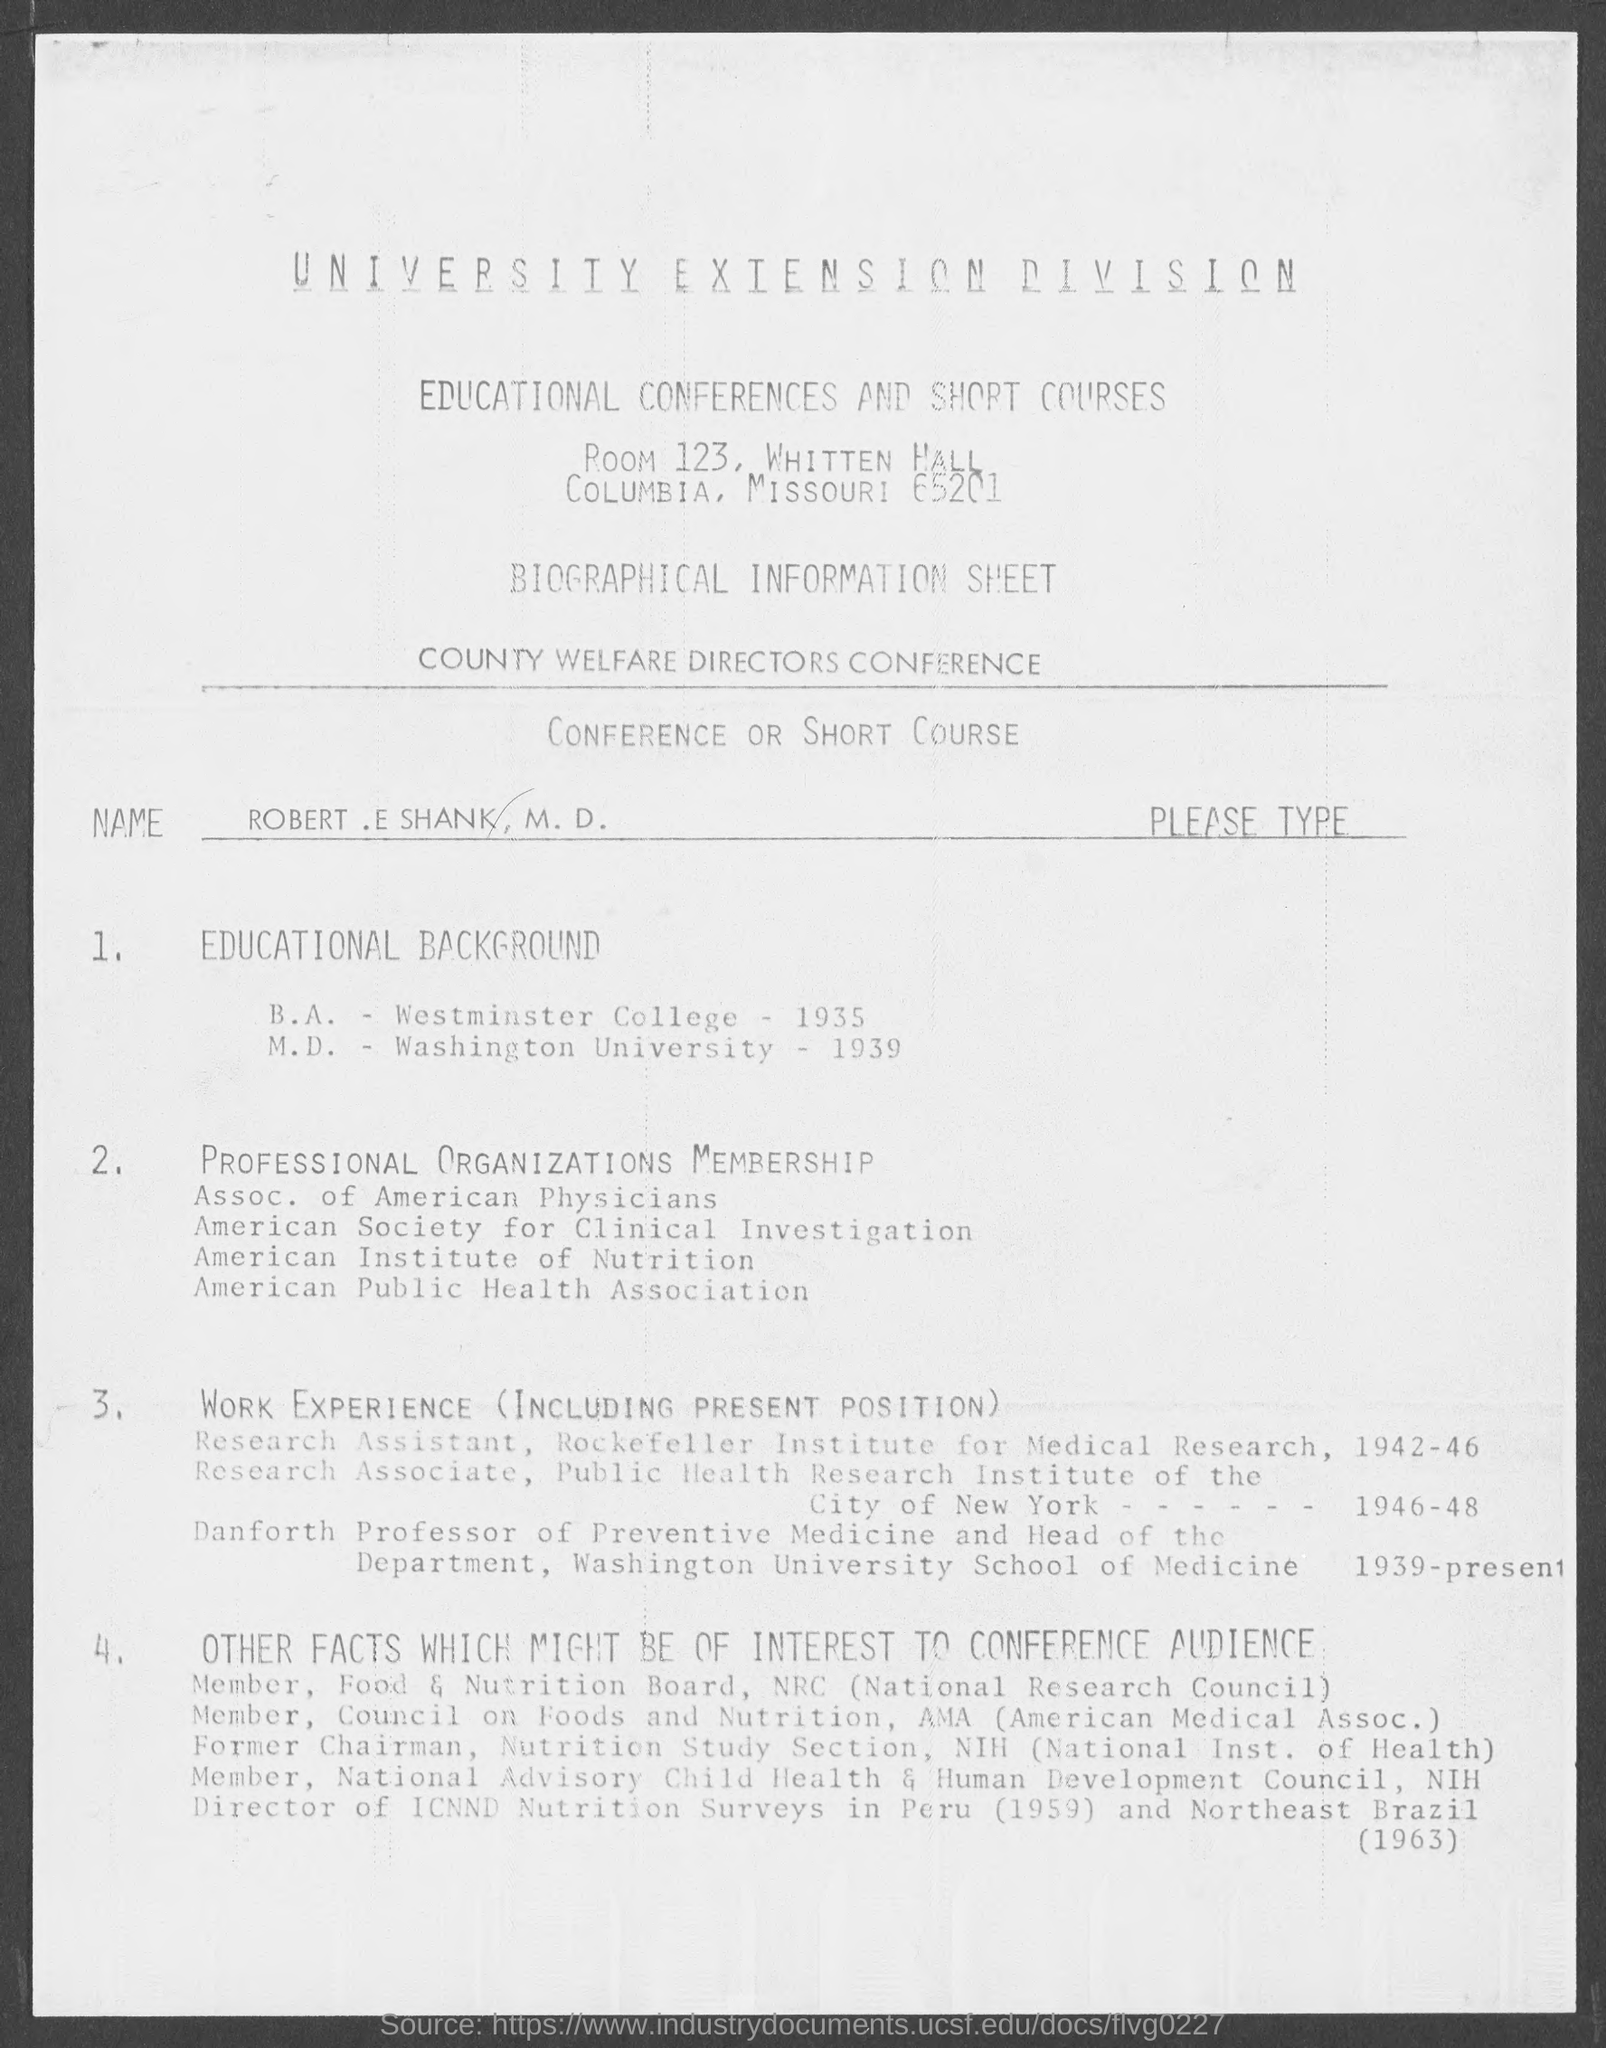Identify some key points in this picture. Robert E. Shank obtained his B.A. degree from Westminster College in 1935. Robert E. Shank completed his M.D. degree at Washington University. 